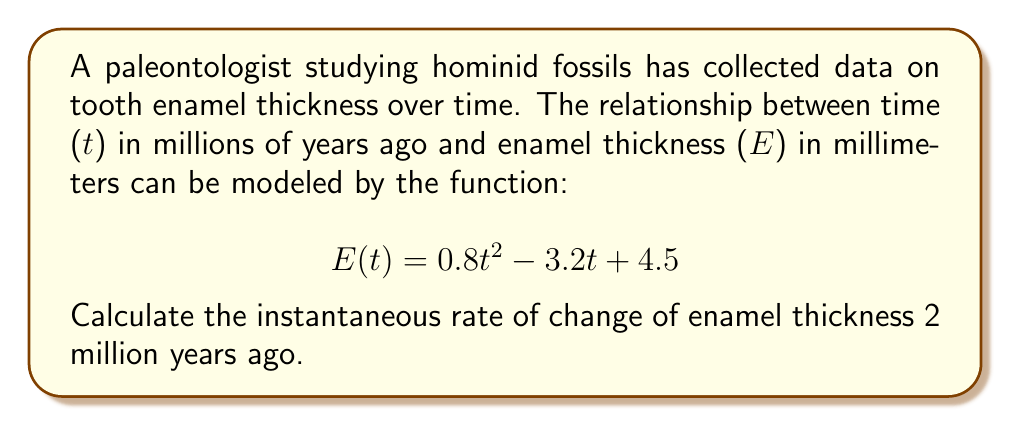Could you help me with this problem? To find the instantaneous rate of change, we need to calculate the derivative of the function E(t) and then evaluate it at t = 2.

Step 1: Find the derivative of E(t)
The function is a quadratic equation, so we can use the power rule to differentiate:
$$E'(t) = \frac{d}{dt}(0.8t^2 - 3.2t + 4.5)$$
$$E'(t) = 1.6t - 3.2$$

Step 2: Evaluate E'(t) at t = 2
Substitute t = 2 into the derivative function:
$$E'(2) = 1.6(2) - 3.2$$
$$E'(2) = 3.2 - 3.2 = 0$$

The instantaneous rate of change is 0 mm/million years at t = 2 million years ago. This indicates that the enamel thickness was at a turning point (either a local maximum or minimum) 2 million years ago.
Answer: $0$ mm/million years 